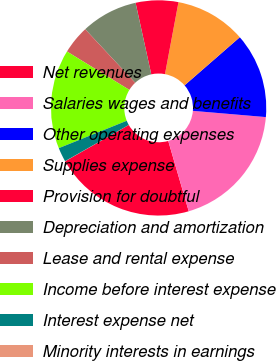<chart> <loc_0><loc_0><loc_500><loc_500><pie_chart><fcel>Net revenues<fcel>Salaries wages and benefits<fcel>Other operating expenses<fcel>Supplies expense<fcel>Provision for doubtful<fcel>Depreciation and amortization<fcel>Lease and rental expense<fcel>Income before interest expense<fcel>Interest expense net<fcel>Minority interests in earnings<nl><fcel>21.25%<fcel>19.13%<fcel>12.76%<fcel>10.64%<fcel>6.39%<fcel>8.51%<fcel>4.27%<fcel>14.88%<fcel>2.14%<fcel>0.02%<nl></chart> 